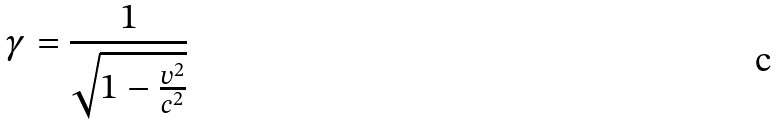<formula> <loc_0><loc_0><loc_500><loc_500>\gamma = \frac { 1 } { \sqrt { 1 - \frac { v ^ { 2 } } { c ^ { 2 } } } }</formula> 